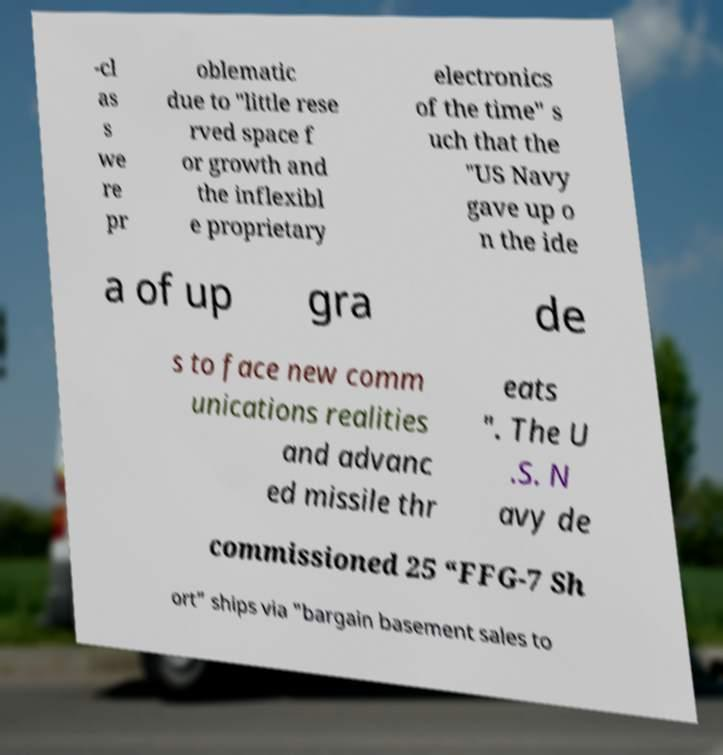Please read and relay the text visible in this image. What does it say? -cl as s we re pr oblematic due to "little rese rved space f or growth and the inflexibl e proprietary electronics of the time" s uch that the "US Navy gave up o n the ide a of up gra de s to face new comm unications realities and advanc ed missile thr eats ". The U .S. N avy de commissioned 25 “FFG-7 Sh ort” ships via "bargain basement sales to 